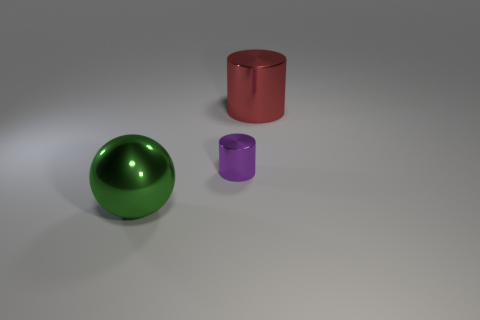What color is the sphere that is the same material as the big red thing?
Keep it short and to the point. Green. How many green things are the same size as the red thing?
Offer a very short reply. 1. What number of gray objects are either small metallic balls or large metal things?
Keep it short and to the point. 0. How many objects are either large red shiny cylinders or metal cylinders in front of the red cylinder?
Keep it short and to the point. 2. There is a big thing right of the green shiny object; what is it made of?
Offer a very short reply. Metal. The green metal object that is the same size as the red shiny cylinder is what shape?
Your answer should be very brief. Sphere. Is there a small gray object of the same shape as the large red object?
Your response must be concise. No. Do the tiny purple cylinder and the large thing behind the big green metallic object have the same material?
Keep it short and to the point. Yes. The big thing that is to the left of the red metallic thing behind the purple metallic cylinder is made of what material?
Give a very brief answer. Metal. Is the number of large red cylinders that are in front of the sphere greater than the number of big red metallic cylinders?
Ensure brevity in your answer.  No. 